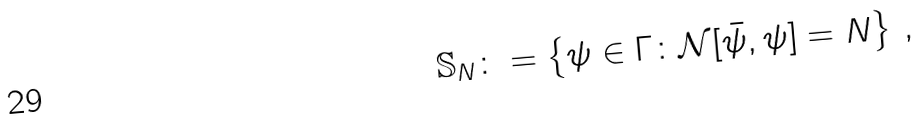<formula> <loc_0><loc_0><loc_500><loc_500>\mathbb { S } _ { N } \colon = \left \{ \psi \in \Gamma \colon \mathcal { N } [ \bar { \psi } , \psi ] = N \right \} \, ,</formula> 